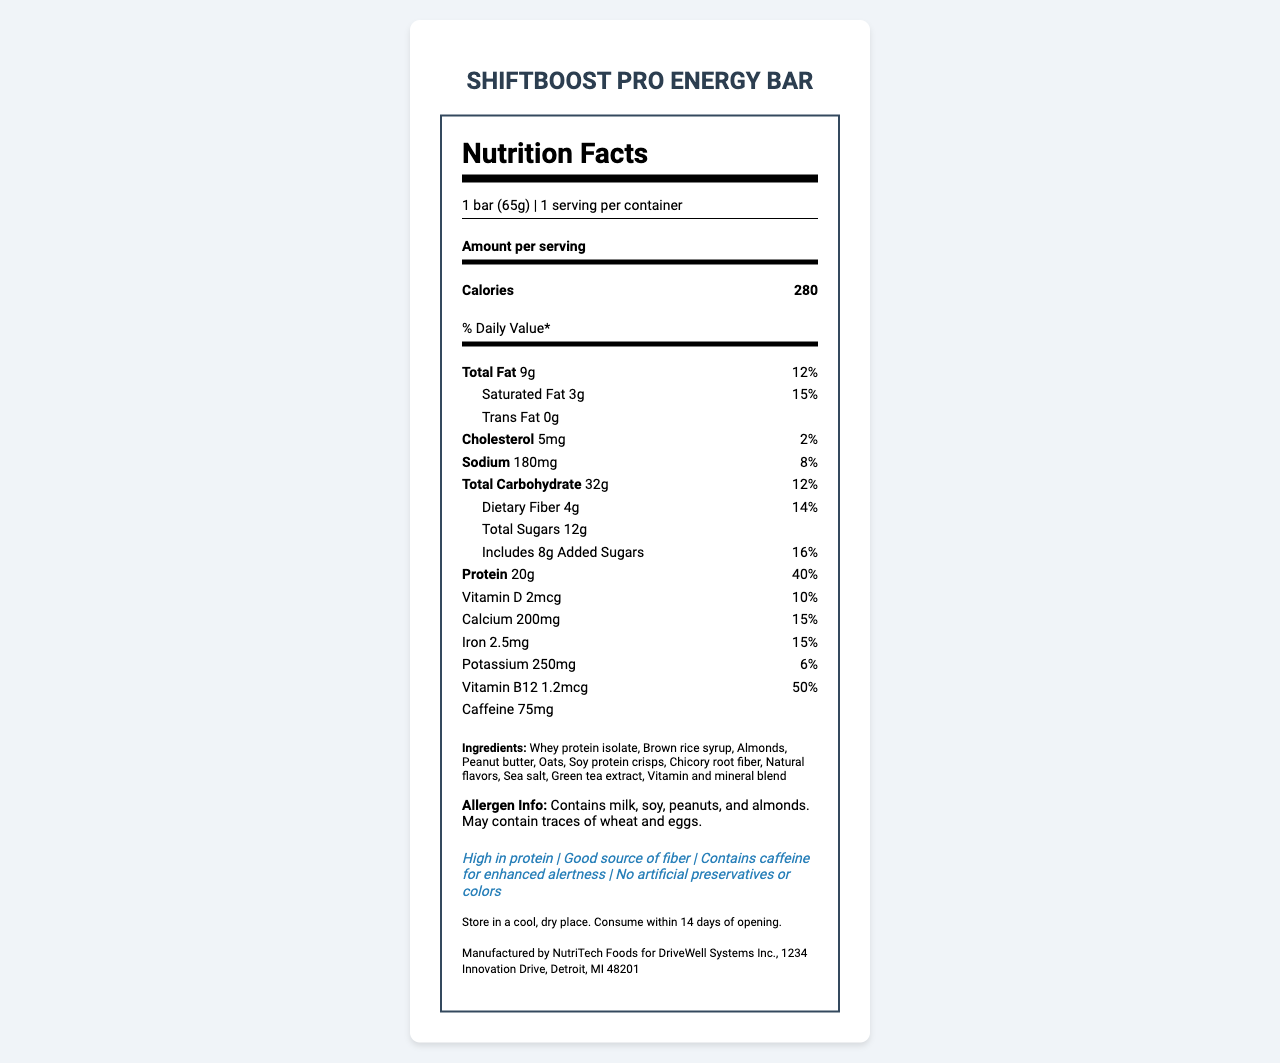what is the serving size for the ShiftBoost Pro Energy Bar? The serving size is explicitly listed as "1 bar (65g)" under the serving information section.
Answer: 1 bar (65g) how many calories are in one serving? The number of calories per serving is clearly shown as "280" in the document.
Answer: 280 what is the total fat content per serving? The total fat per serving is listed as "9g" in the nutrient section.
Answer: 9g what percentage of the daily value of cholesterol does one serving provide? The daily value percentage for cholesterol is indicated as "2%" next to the cholesterol amount.
Answer: 2% how much fiber does the ShiftBoost Pro Energy Bar contain? The amount of dietary fiber is specified as "4g" in the nutrient section.
Answer: 4g which ingredient is listed first in the ingredients list? A. Almonds B. Whey protein isolate C. Chicory root fiber The first ingredient listed is "Whey protein isolate".
Answer: B what is the daily value percentage for protein? A. 30% B. 40% C. 50% The daily value percentage for protein is listed as "40%" in the nutrient section.
Answer: B does this energy bar contain caffeine? The document notes the presence of caffeine with a quantity of "75mg".
Answer: Yes summarize the main features of the ShiftBoost Pro Energy Bar. The product is highlighted as an energy bar that ensures high protein intake with added benefits like fiber and caffeine. Its nutritional content and ingredients reflect these features, aiming to support sustained energy and alertness.
Answer: The ShiftBoost Pro Energy Bar is a high-protein (20g) energy bar designed for long work shifts. It provides 280 calories per serving, contains 9g total fat, 32g carbohydrate, and 4g fiber. It includes vitamins and minerals like calcium, iron, and vitamin B12, and has 75mg of caffeine. The bar is high in protein, a good source of fiber, and contains no artificial preservatives or colors. what is the main ingredient providing protein in the ShiftBoost Pro Energy Bar? The primary ingredient providing protein in the bar is "Whey protein isolate," listed first in the ingredients.
Answer: Whey protein isolate can the bar be stored in a refrigerator? The storage instructions only state "Store in a cool, dry place," and do not specify refrigeration.
Answer: Not mentioned does this energy bar have any added sugars? The document shows that there are "8g" of added sugars included in the total of "12g" sugars.
Answer: Yes how long can the bar be consumed after opening? The consumption period post-opening is specified as "Consume within 14 days of opening."
Answer: 14 days identify a health claim made about the product. One of the health claims indicated in the document is "High in protein."
Answer: High in protein is there any allergen related warning for this product? The document provides allergen information which includes milk, soy, peanuts, and almonds, and mentions possible traces of wheat and eggs.
Answer: Yes who manufactures the ShiftBoost Pro Energy Bar? The manufacturer information is explicitly listed as "Manufactured by NutriTech Foods for DriveWell Systems Inc., 1234 Innovation Drive, Detroit, MI 48201."
Answer: NutriTech Foods for DriveWell Systems Inc. how many vitamins and minerals are listed in the nutritional section? The vitamins and minerals listed include vitamin D, calcium, iron, and vitamin B12.
Answer: 4 have any artificial preservatives been used in this energy bar? One of the claim statements is "No artificial preservatives or colors," indicating the absence of artificial preservatives.
Answer: No 